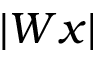Convert formula to latex. <formula><loc_0><loc_0><loc_500><loc_500>| W x |</formula> 